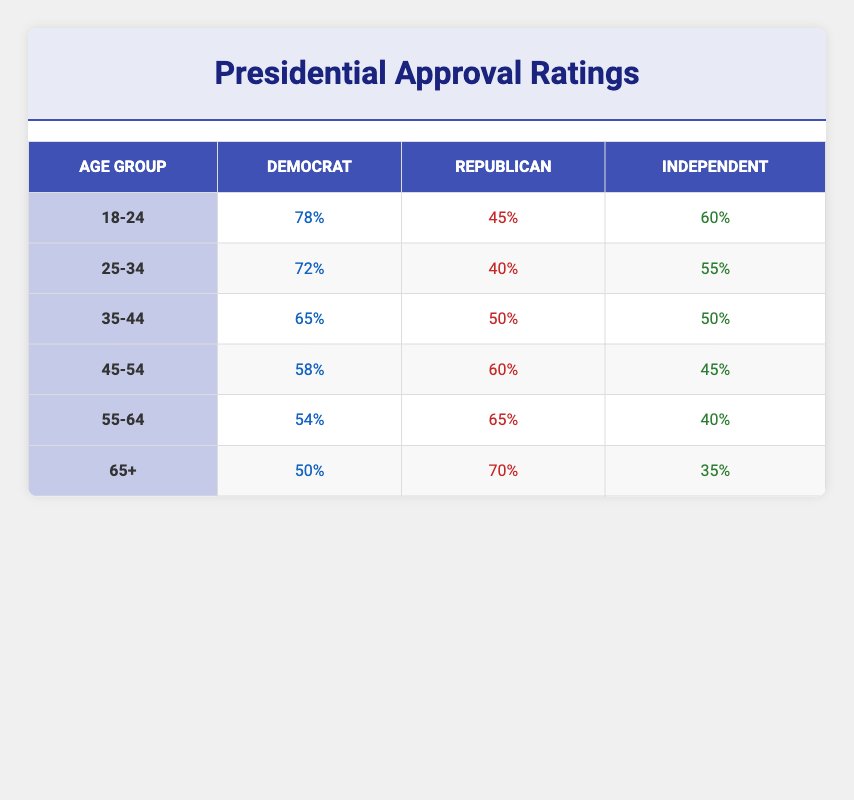What is the approval rating for Democrats in the 45-54 age group? According to the table, the approval rating for Democrats in the 45-54 age group is listed as 58%.
Answer: 58% In which age group do Republicans have the highest approval rating? By comparing the Republican approval ratings across all age groups, the highest value is 70%, which occurs in the 65+ age group.
Answer: 65+ What is the average approval rating for Independents across all age groups? To find the average, sum the approval ratings for Independents: (60 + 55 + 50 + 45 + 40 + 35) = 285. Then, divide by the number of age groups (6): 285/6 = 47.5.
Answer: 47.5 Do more Independents or Democrats approve of the President in the 25-34 age group? In the 25-34 age group, Democrats have an approval rating of 72%, while Independents have 55%. Since 72% is greater than 55%, more Democrats approve of the President in this age group.
Answer: Yes What is the difference in approval ratings between Republicans in the 18-24 and 45-54 age groups? The approval rating for Republicans in the 18-24 age group is 45%, and in the 45-54 age group, it's 60%. To find the difference, subtract the 18-24 rating from the 45-54 rating: 60 - 45 = 15.
Answer: 15 Is the approval rating for Democrats in the 55-64 age group higher than that for Independents in the same age group? The approval rating for Democrats in the 55-64 age group is 54%, and for Independents, it is 40%. Since 54% is greater than 40%, the statement is true.
Answer: Yes What is the lowest approval rating among Independents, and in which age group does it occur? Looking at the Independents' approval ratings, the lowest value is 35%, which appears in the 65+ age group, making it the age group with the lowest approval rating for Independents.
Answer: 35% in the 65+ age group Which age group shows the least support for the President from Republicans? By comparing the Republican approval ratings of all age groups, the lowest support occurs in the 25-34 age group with a rating of 40%.
Answer: 25-34 age group What is the combined approval rating of Independents and Democrats in the 18-24 age group? For the 18-24 age group, Democrats have a rating of 78% and Independents have 60%. Adding these two values together gives: 78 + 60 = 138.
Answer: 138 